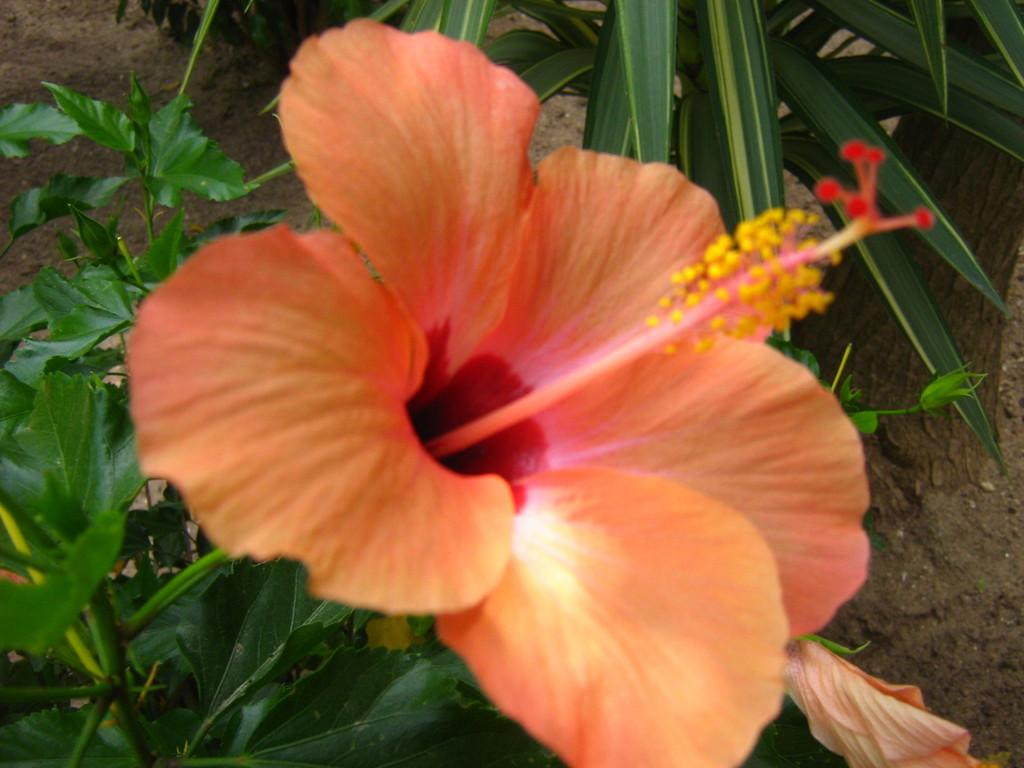What color is the flower in the image? The flower in the image is orange. What color are the leaves in the image? The leaves in the image are green. What type of band is playing in the background of the image? There is no band present in the image; it only features an orange flower and green leaves. 